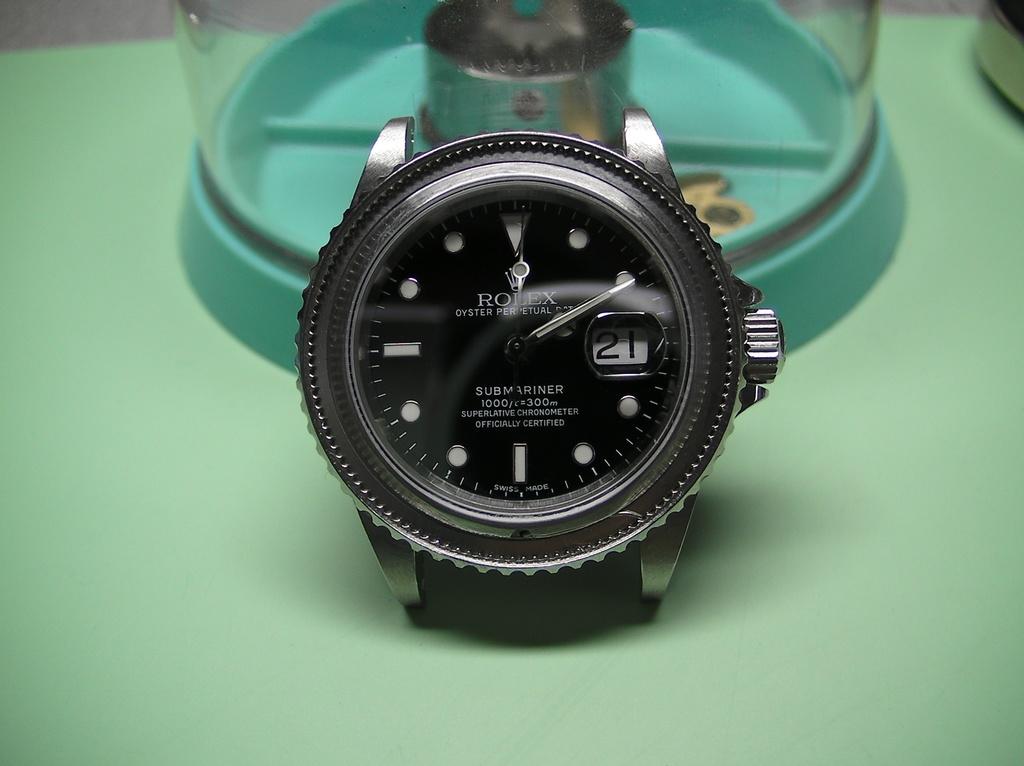What brand is the watch?
Offer a terse response. Rolex. 